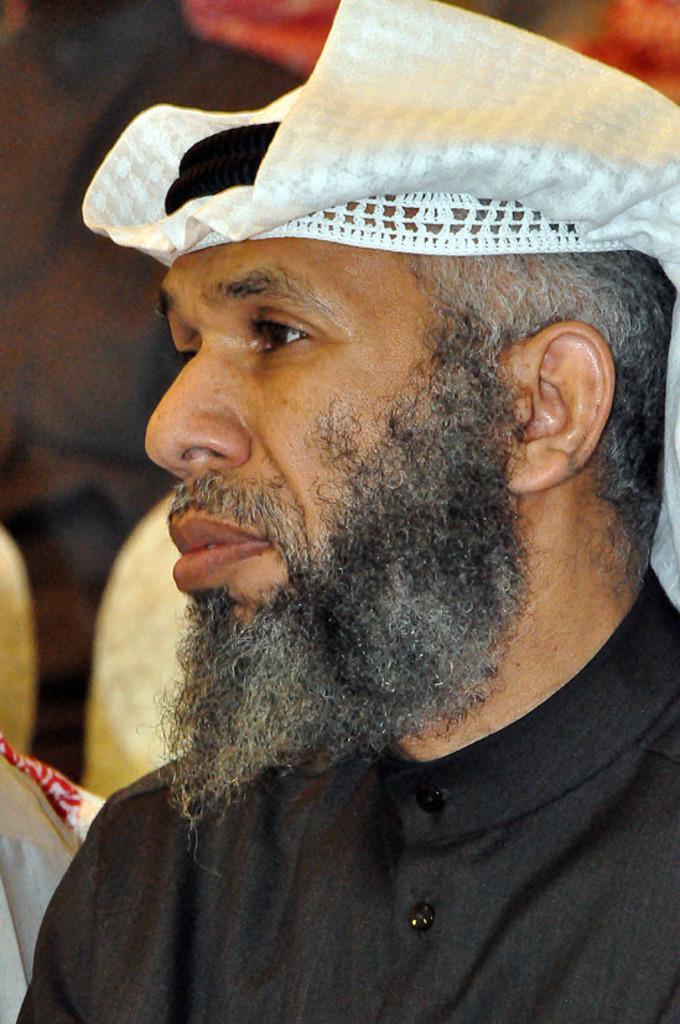Who is the main subject in the image? There is a man in the image. What is the man doing in the image? The man is sitting on a chair. Can you describe the background of the image? The background of the image is blurred. What type of prose is the man reading in the image? There is no indication in the image that the man is reading any prose, as the image does not show any books or written material. 